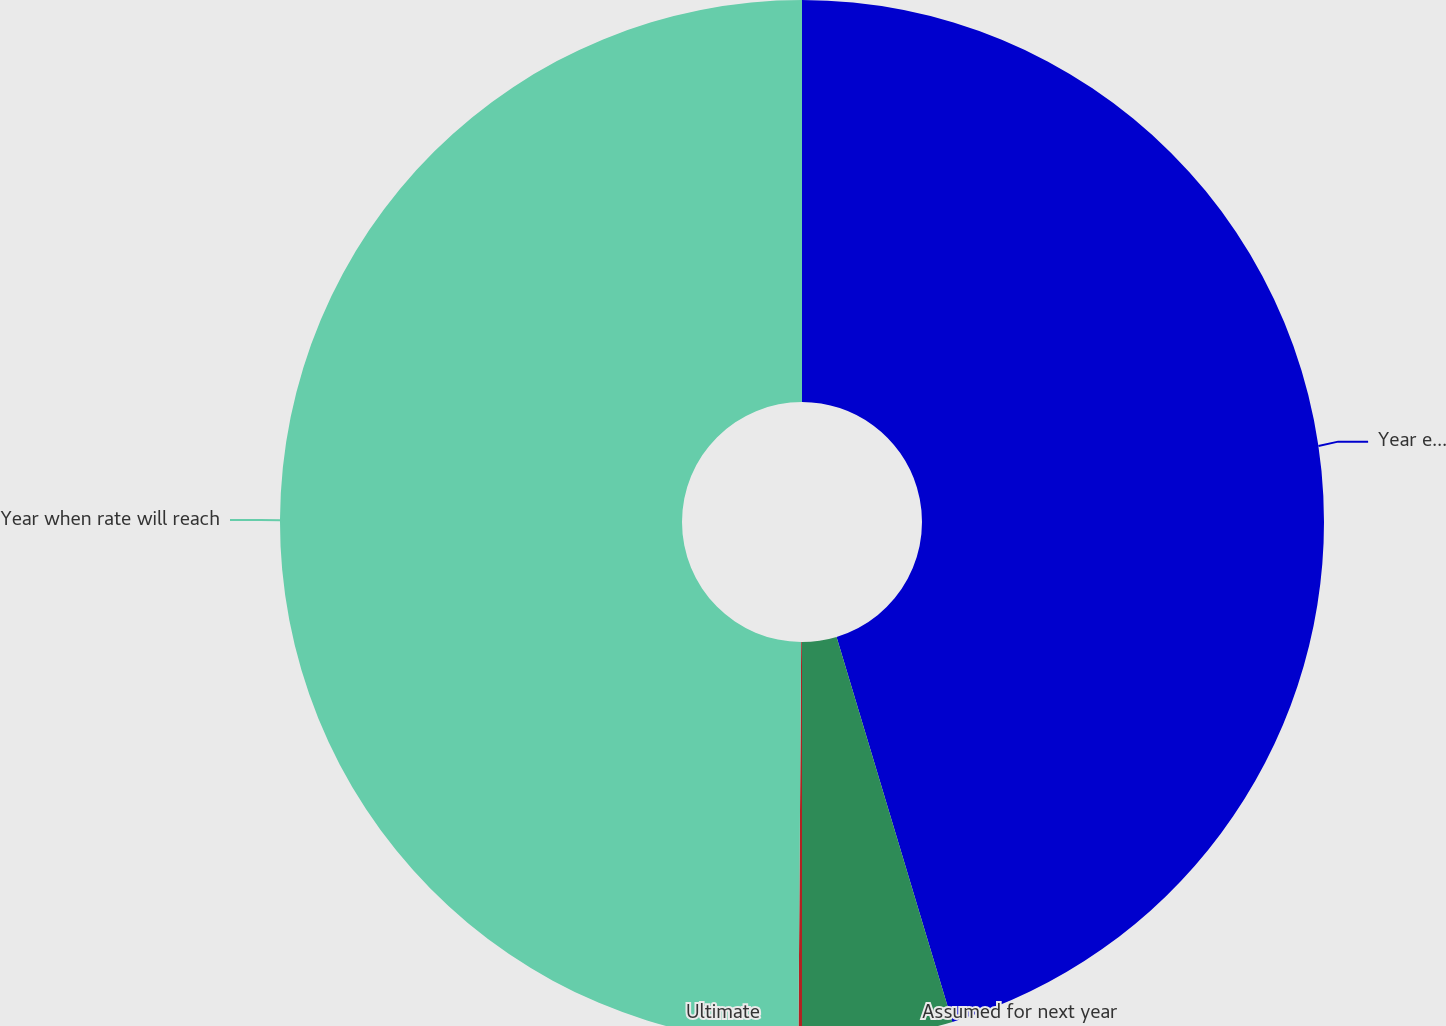<chart> <loc_0><loc_0><loc_500><loc_500><pie_chart><fcel>Year ended December 31<fcel>Assumed for next year<fcel>Ultimate<fcel>Year when rate will reach<nl><fcel>45.35%<fcel>4.65%<fcel>0.11%<fcel>49.89%<nl></chart> 